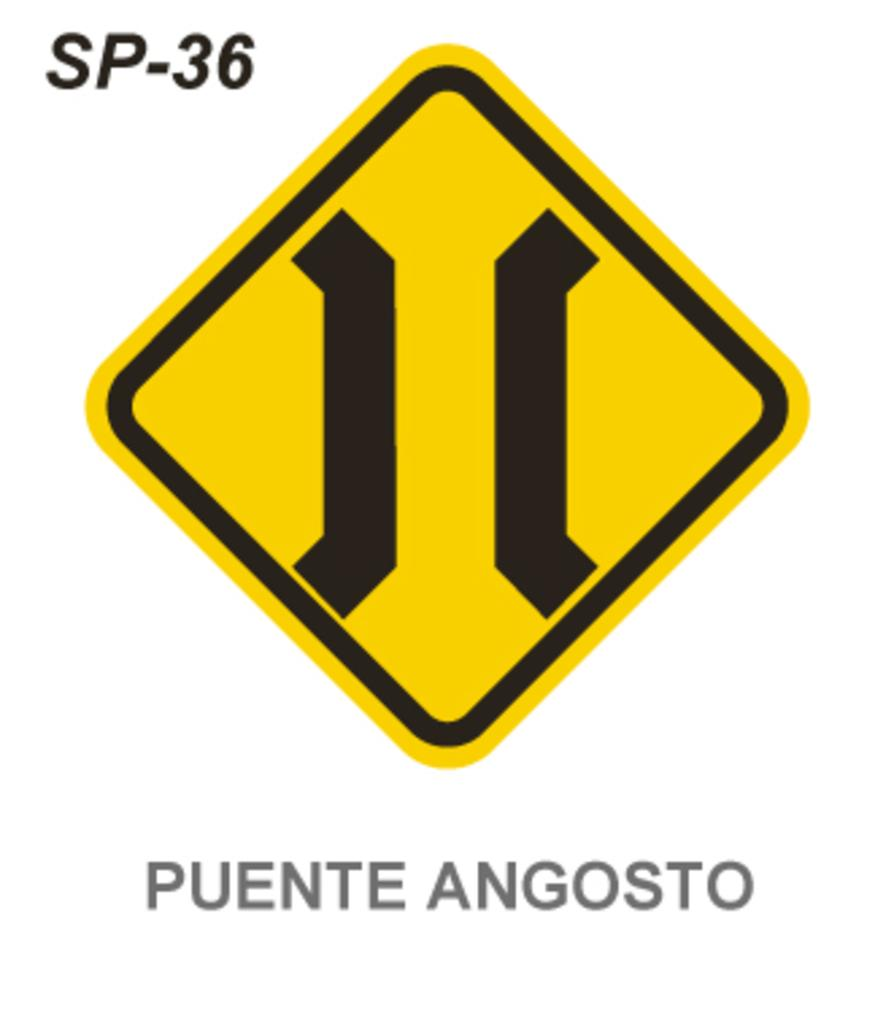<image>
Render a clear and concise summary of the photo. A diamond shaped yellow and black sign has the words Puente Angosto underneath. 